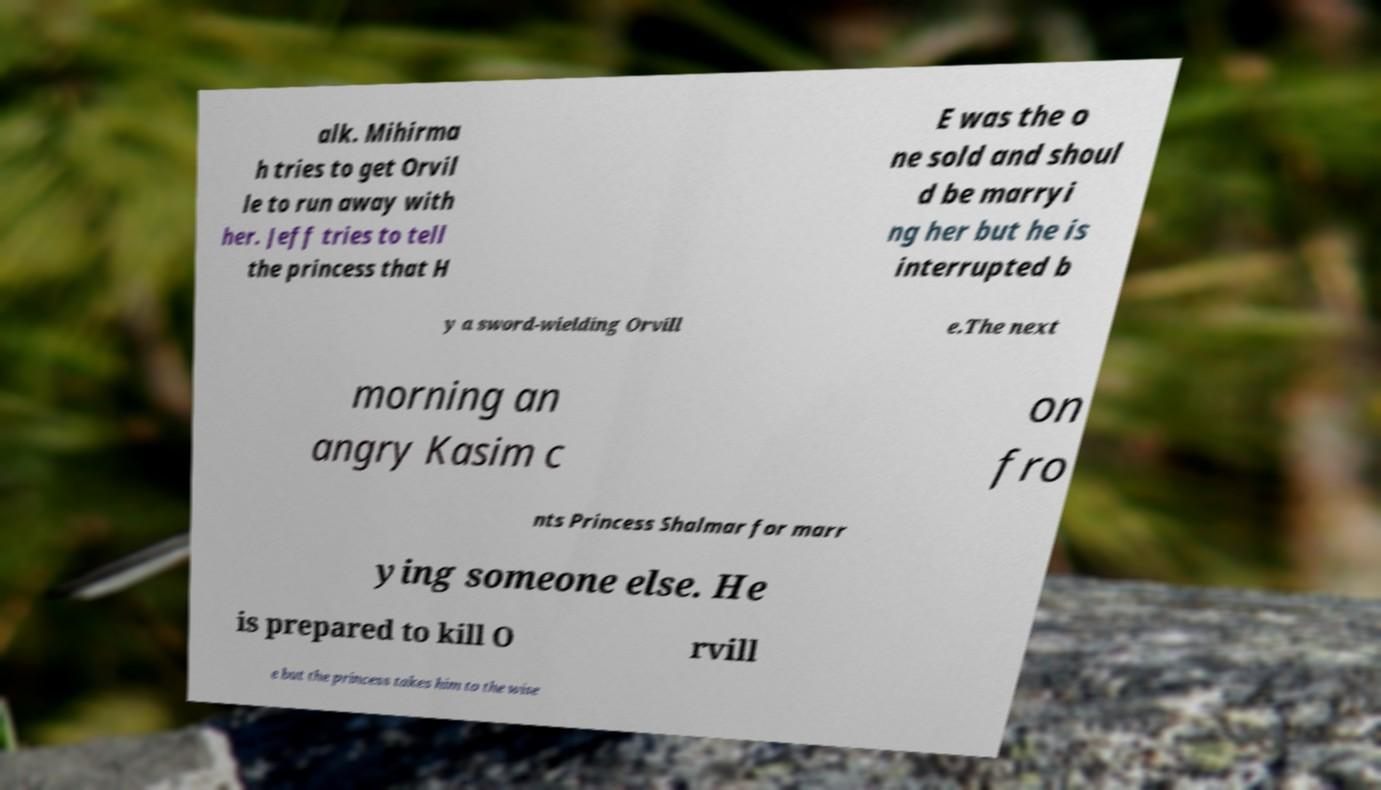Can you accurately transcribe the text from the provided image for me? alk. Mihirma h tries to get Orvil le to run away with her. Jeff tries to tell the princess that H E was the o ne sold and shoul d be marryi ng her but he is interrupted b y a sword-wielding Orvill e.The next morning an angry Kasim c on fro nts Princess Shalmar for marr ying someone else. He is prepared to kill O rvill e but the princess takes him to the wise 